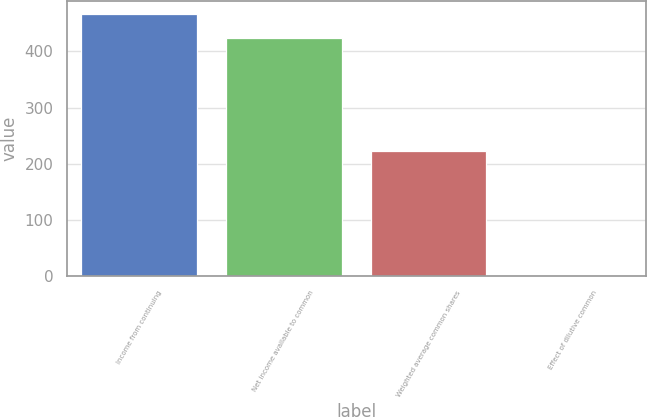<chart> <loc_0><loc_0><loc_500><loc_500><bar_chart><fcel>Income from continuing<fcel>Net income available to common<fcel>Weighted average common shares<fcel>Effect of dilutive common<nl><fcel>465.9<fcel>423<fcel>221.9<fcel>1<nl></chart> 